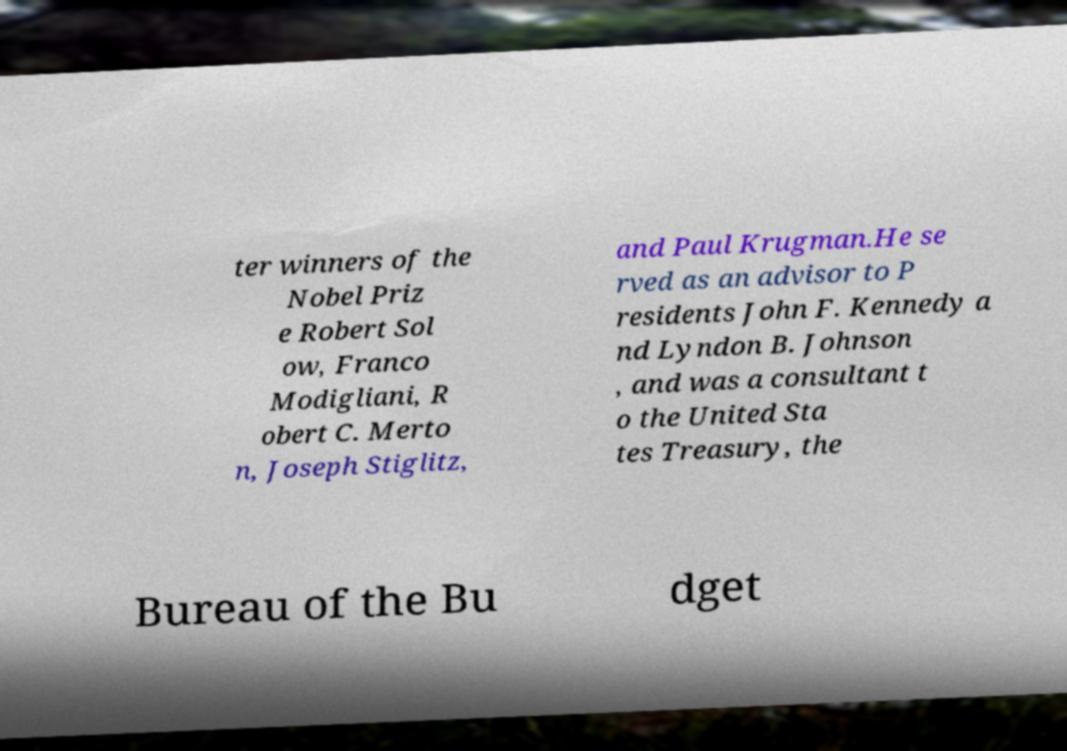I need the written content from this picture converted into text. Can you do that? ter winners of the Nobel Priz e Robert Sol ow, Franco Modigliani, R obert C. Merto n, Joseph Stiglitz, and Paul Krugman.He se rved as an advisor to P residents John F. Kennedy a nd Lyndon B. Johnson , and was a consultant t o the United Sta tes Treasury, the Bureau of the Bu dget 